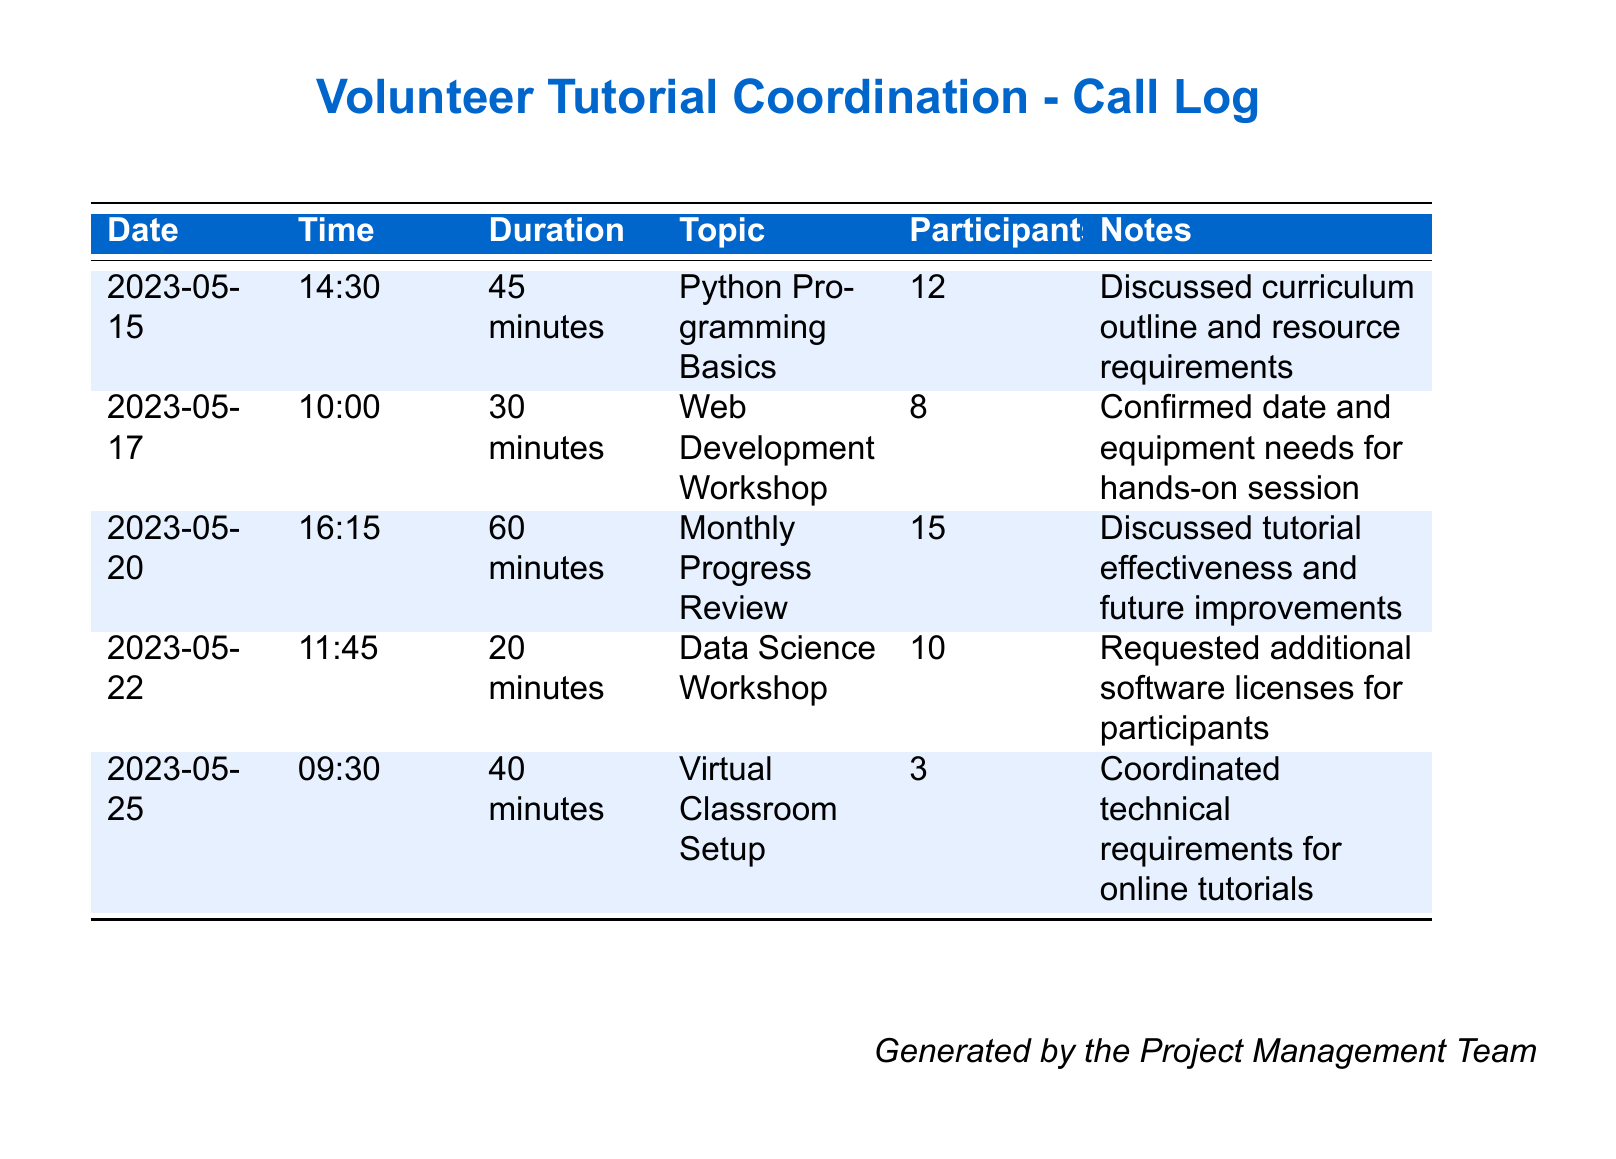What is the date of the Python Programming Basics session? The date can be found in the first row of the table under the Date column.
Answer: 2023-05-15 How many participants attended the Web Development Workshop? The number of participants is listed in the second row under the Participants column.
Answer: 8 What was the duration of the Monthly Progress Review? The duration is provided in the third row under the Duration column.
Answer: 60 minutes What topic was discussed on May 22? The topic can be found in the fourth row under the Topic column, corresponding to the date.
Answer: Data Science Workshop Which session had the least duration? By comparing the durations listed in the Duration column, the shortest one can be identified.
Answer: 20 minutes How many total participants were involved across all sessions? This requires adding together all the participants listed in the Participants column.
Answer: 48 What was the focus of the meeting on May 25? The focus is indicated in the Topic column for that date.
Answer: Virtual Classroom Setup How many calls were made in total? The number of rows in the table corresponds to the number of calls made.
Answer: 5 Which session required additional software licenses for participants? The notes for the fourth row indicate this requirement.
Answer: Data Science Workshop 